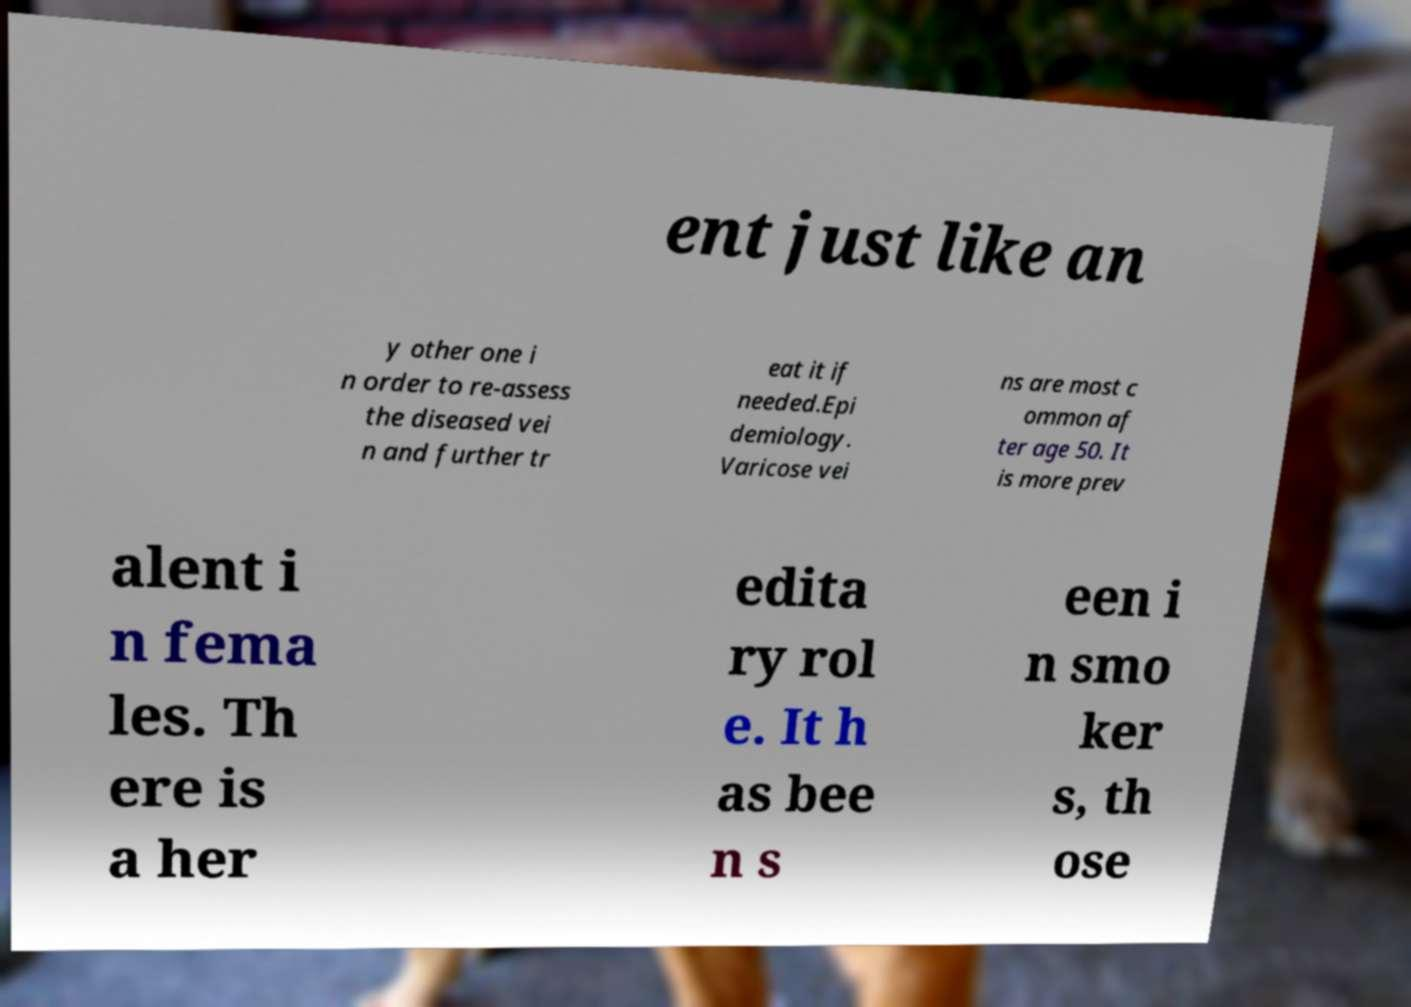Can you read and provide the text displayed in the image?This photo seems to have some interesting text. Can you extract and type it out for me? ent just like an y other one i n order to re-assess the diseased vei n and further tr eat it if needed.Epi demiology. Varicose vei ns are most c ommon af ter age 50. It is more prev alent i n fema les. Th ere is a her edita ry rol e. It h as bee n s een i n smo ker s, th ose 